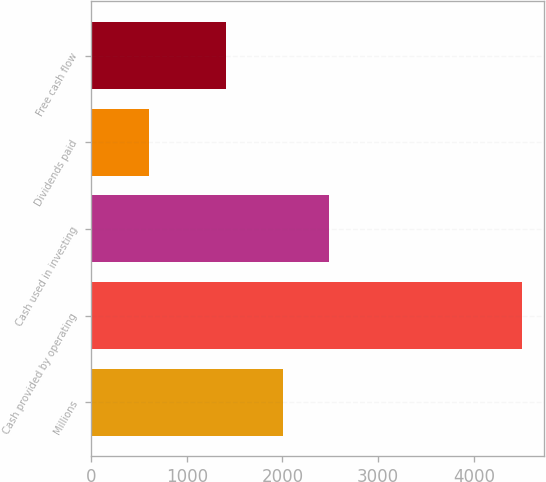<chart> <loc_0><loc_0><loc_500><loc_500><bar_chart><fcel>Millions<fcel>Cash provided by operating<fcel>Cash used in investing<fcel>Dividends paid<fcel>Free cash flow<nl><fcel>2010<fcel>4505<fcel>2488<fcel>602<fcel>1415<nl></chart> 